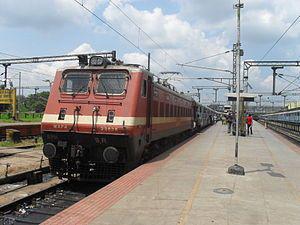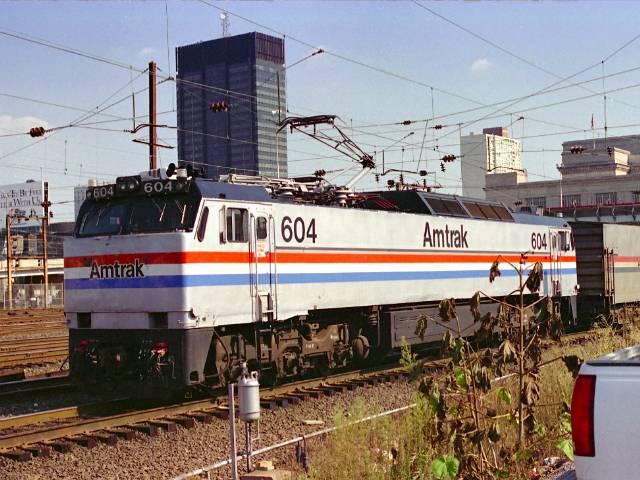The first image is the image on the left, the second image is the image on the right. For the images displayed, is the sentence "Right image shows a white train with a red stripe only and an angled front." factually correct? Answer yes or no. No. The first image is the image on the left, the second image is the image on the right. Evaluate the accuracy of this statement regarding the images: "One train is white with a single red horizontal stripe around the body.". Is it true? Answer yes or no. No. 